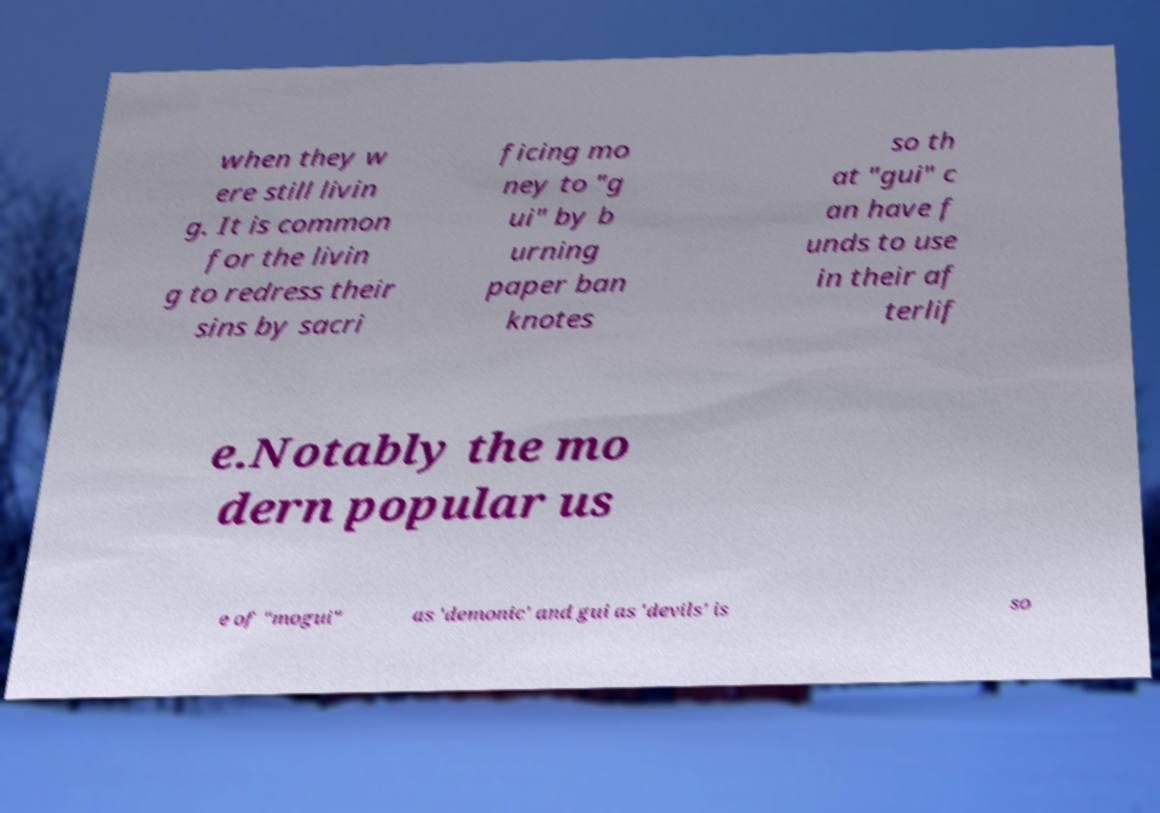Could you assist in decoding the text presented in this image and type it out clearly? when they w ere still livin g. It is common for the livin g to redress their sins by sacri ficing mo ney to "g ui" by b urning paper ban knotes so th at "gui" c an have f unds to use in their af terlif e.Notably the mo dern popular us e of "mogui" as 'demonic' and gui as 'devils' is so 